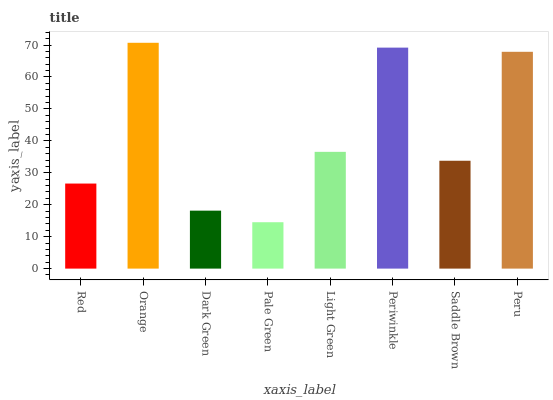Is Pale Green the minimum?
Answer yes or no. Yes. Is Orange the maximum?
Answer yes or no. Yes. Is Dark Green the minimum?
Answer yes or no. No. Is Dark Green the maximum?
Answer yes or no. No. Is Orange greater than Dark Green?
Answer yes or no. Yes. Is Dark Green less than Orange?
Answer yes or no. Yes. Is Dark Green greater than Orange?
Answer yes or no. No. Is Orange less than Dark Green?
Answer yes or no. No. Is Light Green the high median?
Answer yes or no. Yes. Is Saddle Brown the low median?
Answer yes or no. Yes. Is Saddle Brown the high median?
Answer yes or no. No. Is Orange the low median?
Answer yes or no. No. 